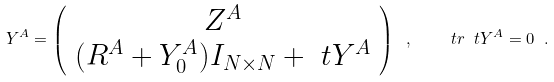Convert formula to latex. <formula><loc_0><loc_0><loc_500><loc_500>Y ^ { A } = \left ( \begin{array} { c c } Z ^ { A } \\ ( R ^ { A } + Y _ { 0 } ^ { A } ) I _ { N \times N } + \ t Y ^ { A } \\ \end{array} \right ) \ , \quad \ t r \ t Y ^ { A } = 0 \ .</formula> 